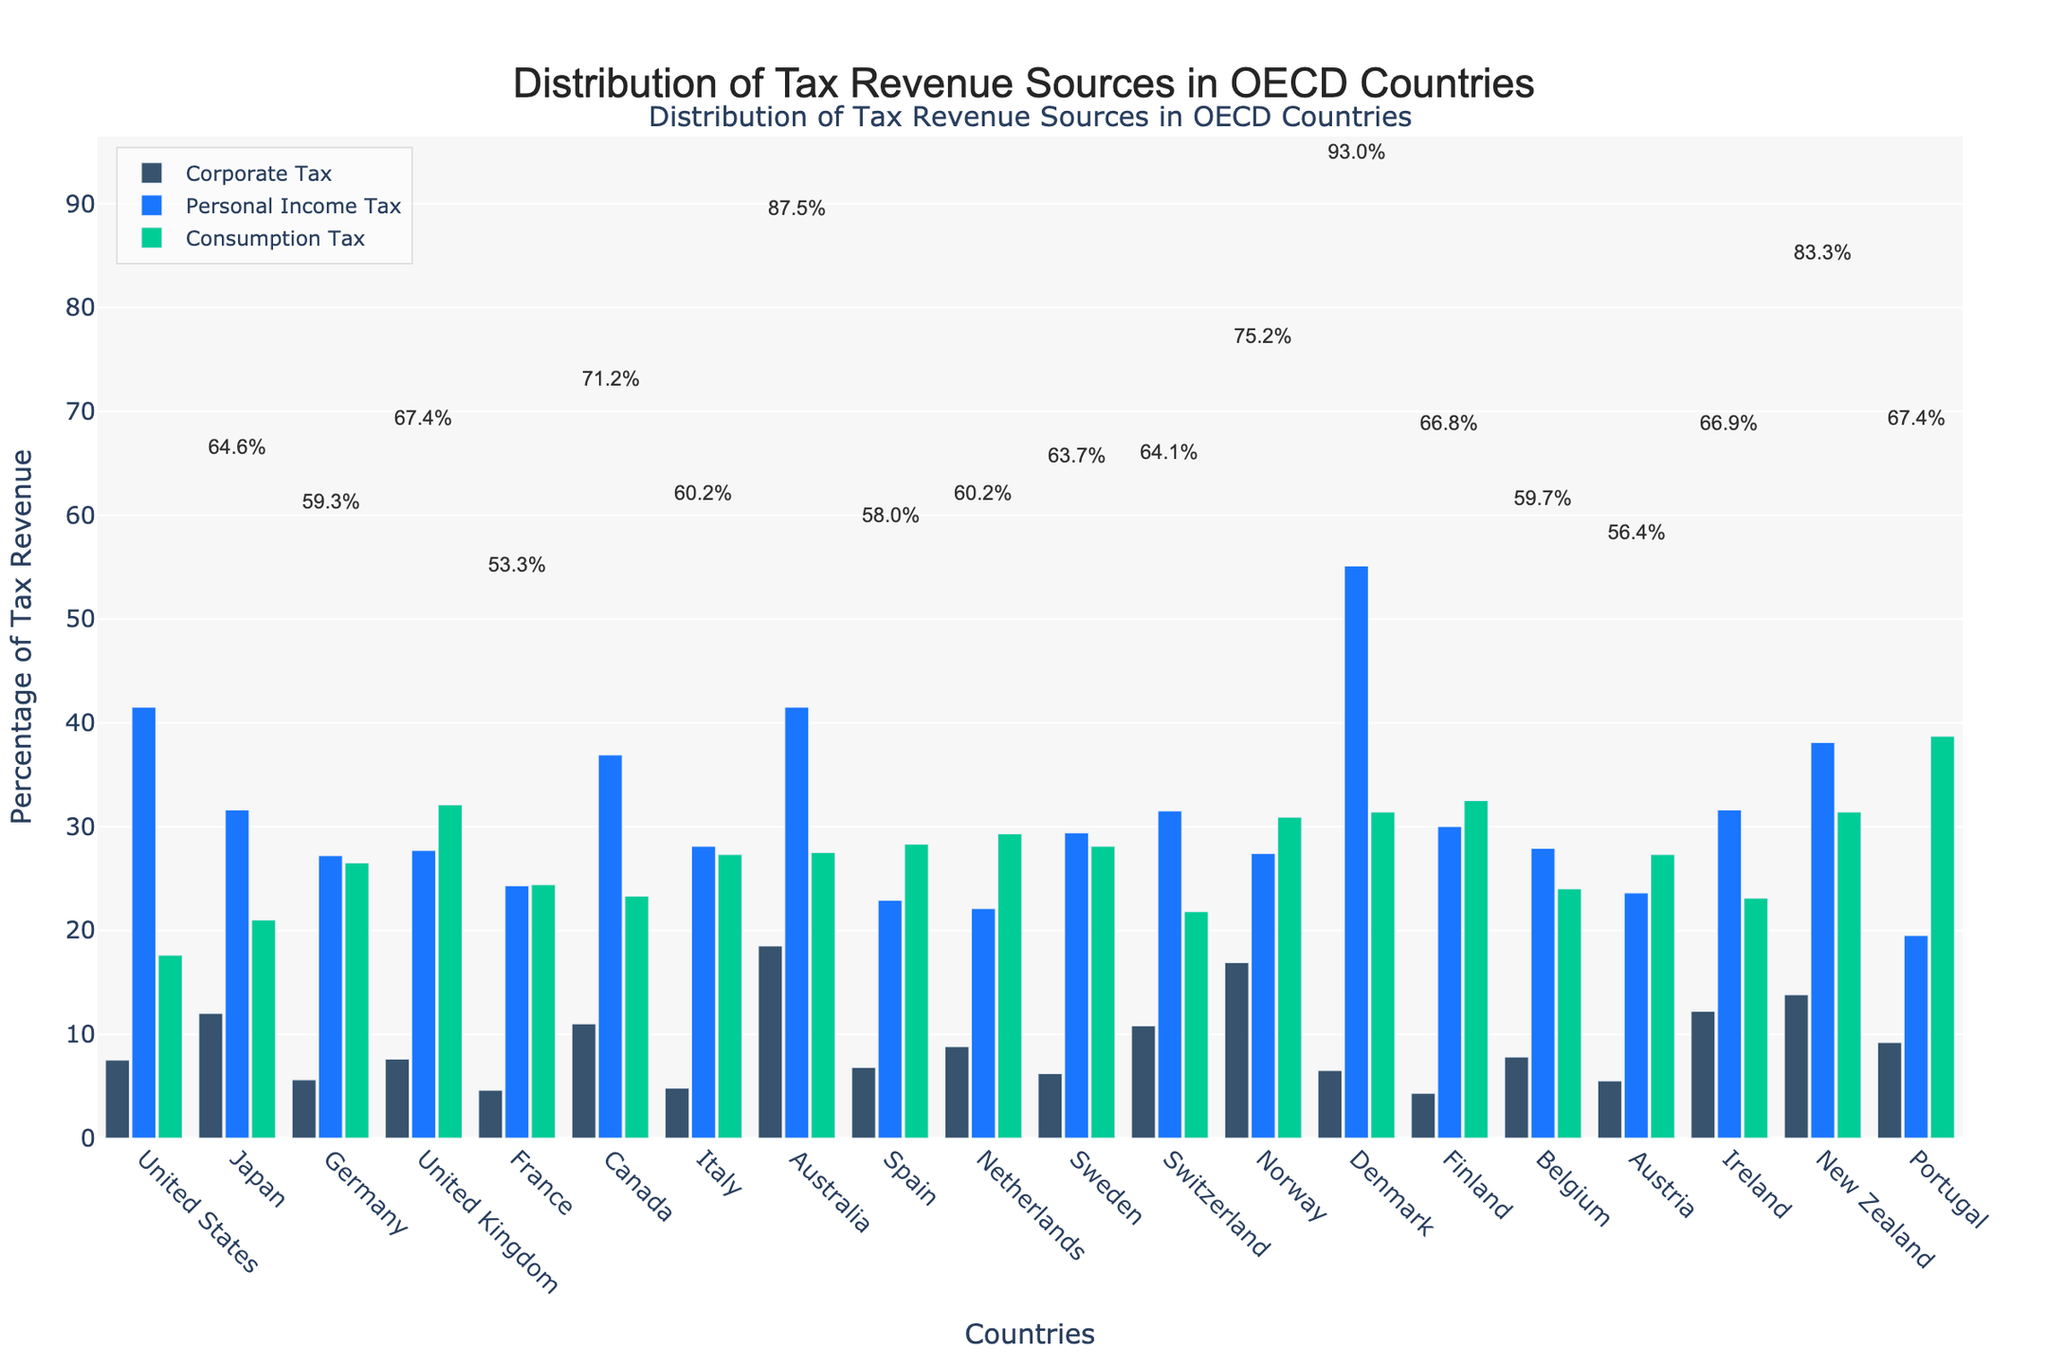Which country has the highest percentage of corporate tax revenue? Look at the heights of the bars representing corporate tax revenue for each country. The tallest bar corresponds to Australia.
Answer: Australia What is the total tax revenue percentage (corporate, personal, and consumption) for Canada? Sum the three tax revenue percentages for Canada: 11.0 + 36.9 + 23.3.
Answer: 71.2% Compare the corporate tax revenue percentages of Japan and Ireland. Which one is higher? Check the height of the bars for corporate tax in Japan and Ireland. Japan's bar is shorter, indicating a lower percentage than Ireland.
Answer: Ireland Among the United Kingdom, Denmark, and Portugal, which country has the highest consumption tax percentage? Compare the heights of the consumption tax bars for the United Kingdom, Denmark, and Portugal. Portugal's bar is the tallest.
Answer: Portugal What is the difference between personal income tax percentage and consumption tax percentage in the Netherlands? Subtract the consumption tax percentage from the personal income tax percentage for the Netherlands: 22.1 - 29.3.
Answer: -7.2% Compare the visual color representation of tax types in the chart. What color represents personal income tax? Identify the color of the bars in the figure that are labeled as personal income tax.
Answer: Blue What is the average corporate tax percentage for the United States, Switzerland, and New Zealand? Sum the corporate tax percentages for the United States (7.5), Switzerland (10.8), and New Zealand (13.8), then divide by 3. (7.5 + 10.8 + 13.8)/3.
Answer: 10.7% Which country has the least reliance on corporate tax, and what is that percentage? Identify the country with the shortest bar for corporate tax, which is Finland.
Answer: 4.3% 